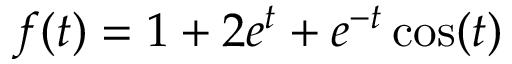Convert formula to latex. <formula><loc_0><loc_0><loc_500><loc_500>f ( t ) = 1 + 2 e ^ { t } + e ^ { - t } \cos ( t )</formula> 